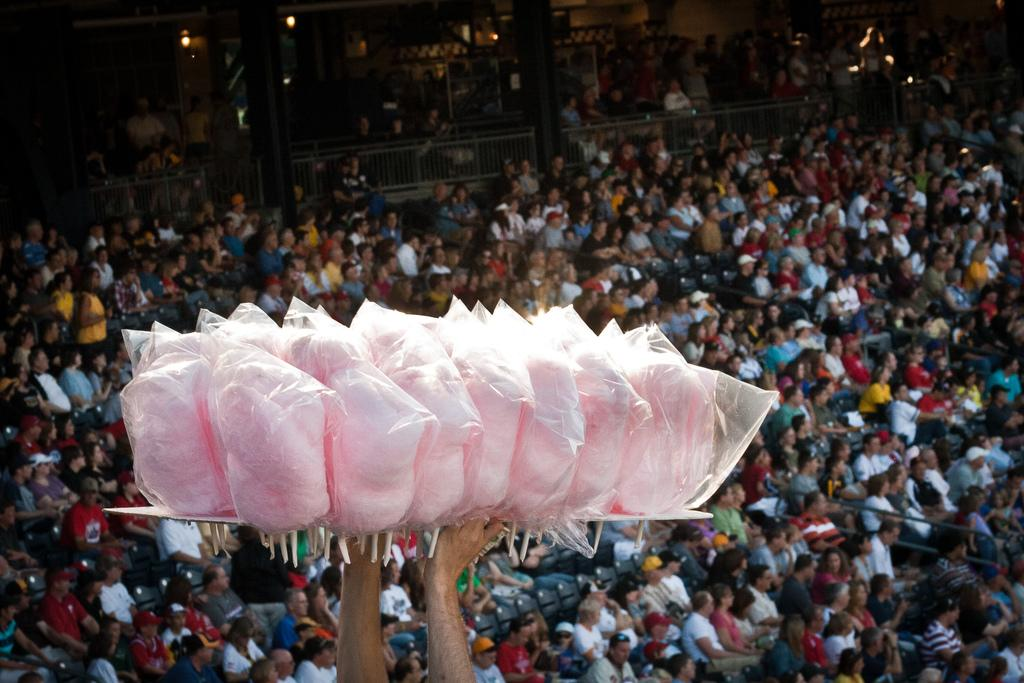What are the people in the image doing? There is a group of people sitting on chairs in the image. What architectural features can be seen in the image? There are pillars and a wall visible in the image. What type of enclosure is present in the image? There is fencing in the image. What can be used for illumination in the image? There are lights in the image. Can you describe what a person is holding in the image? A person is holding pink candy in the image. How many ducks are visible in the image? There are no ducks present in the image. What type of ant can be seen crawling on the wall in the image? There are no ants visible in the image, and therefore no such activity can be observed. 